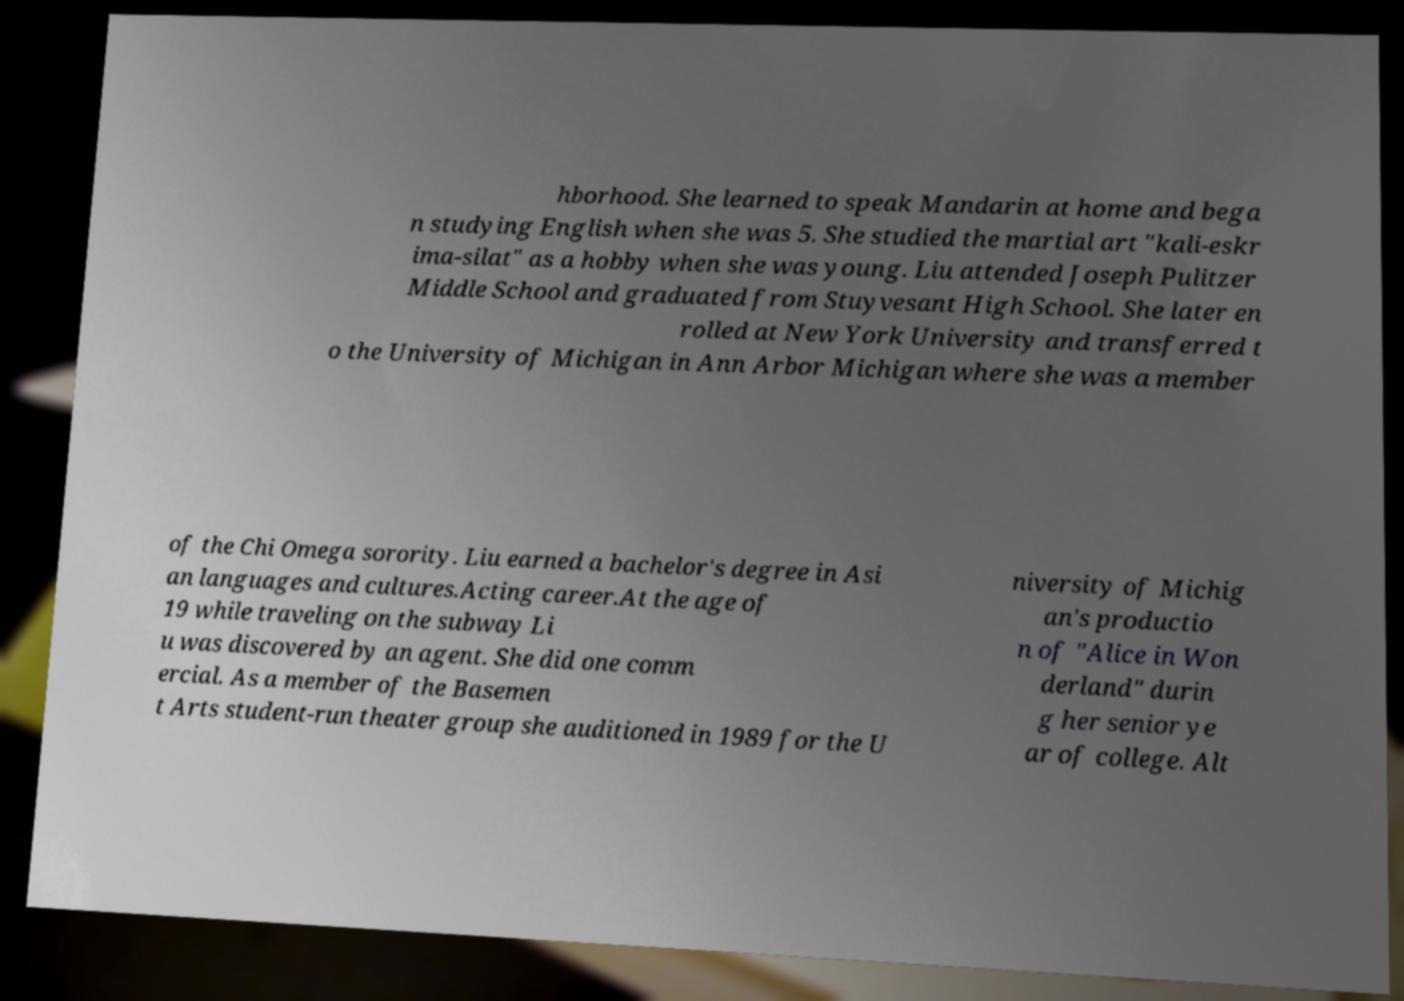Please read and relay the text visible in this image. What does it say? hborhood. She learned to speak Mandarin at home and bega n studying English when she was 5. She studied the martial art "kali-eskr ima-silat" as a hobby when she was young. Liu attended Joseph Pulitzer Middle School and graduated from Stuyvesant High School. She later en rolled at New York University and transferred t o the University of Michigan in Ann Arbor Michigan where she was a member of the Chi Omega sorority. Liu earned a bachelor's degree in Asi an languages and cultures.Acting career.At the age of 19 while traveling on the subway Li u was discovered by an agent. She did one comm ercial. As a member of the Basemen t Arts student-run theater group she auditioned in 1989 for the U niversity of Michig an's productio n of "Alice in Won derland" durin g her senior ye ar of college. Alt 